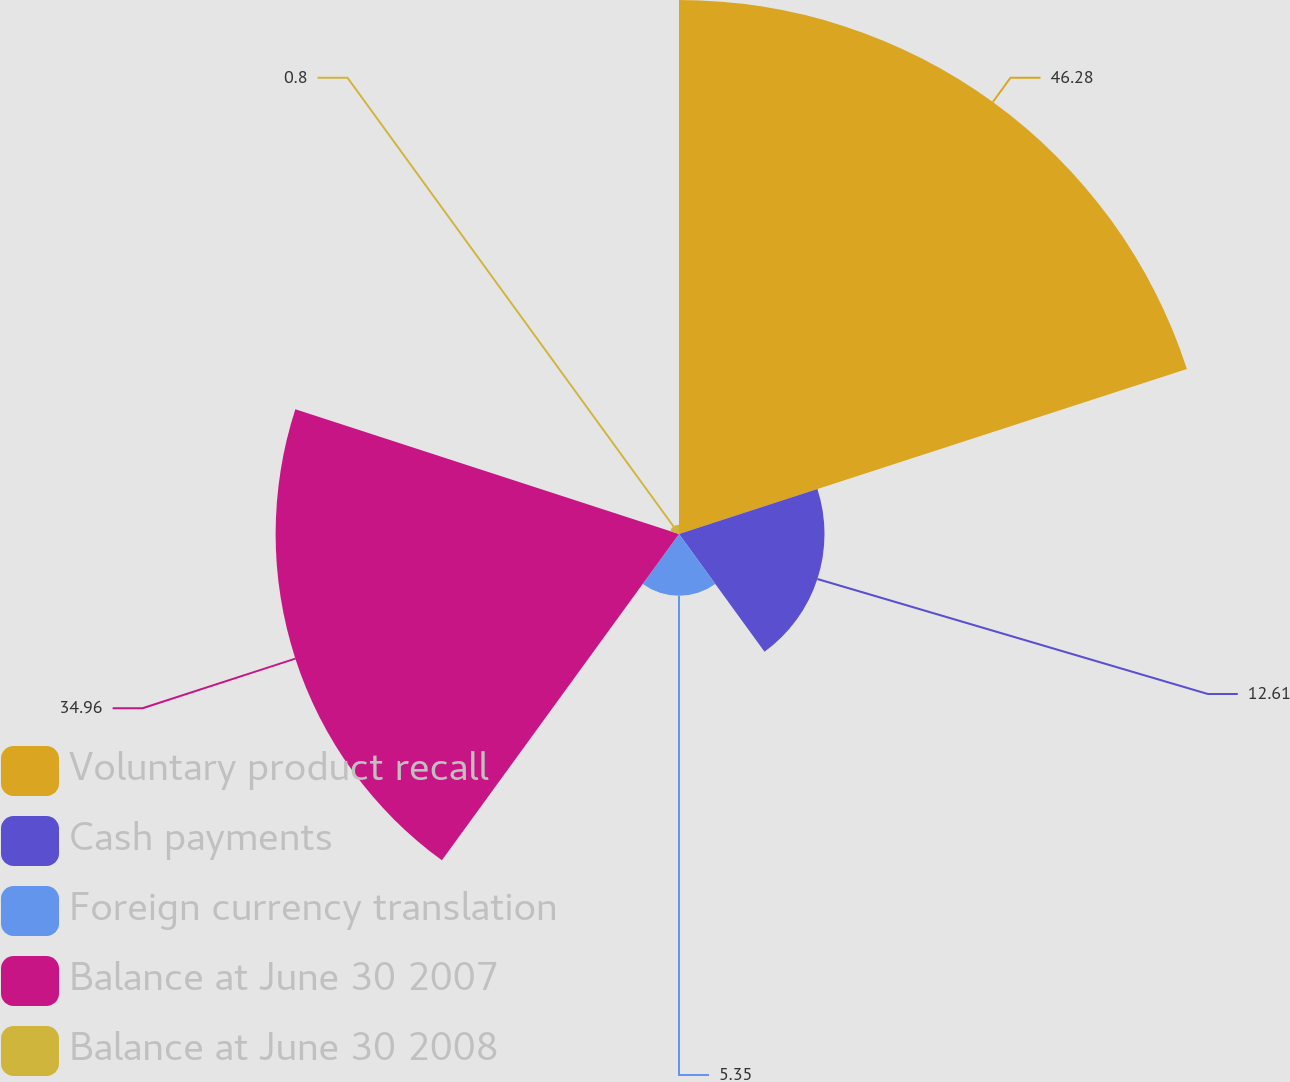Convert chart to OTSL. <chart><loc_0><loc_0><loc_500><loc_500><pie_chart><fcel>Voluntary product recall<fcel>Cash payments<fcel>Foreign currency translation<fcel>Balance at June 30 2007<fcel>Balance at June 30 2008<nl><fcel>46.28%<fcel>12.61%<fcel>5.35%<fcel>34.96%<fcel>0.8%<nl></chart> 